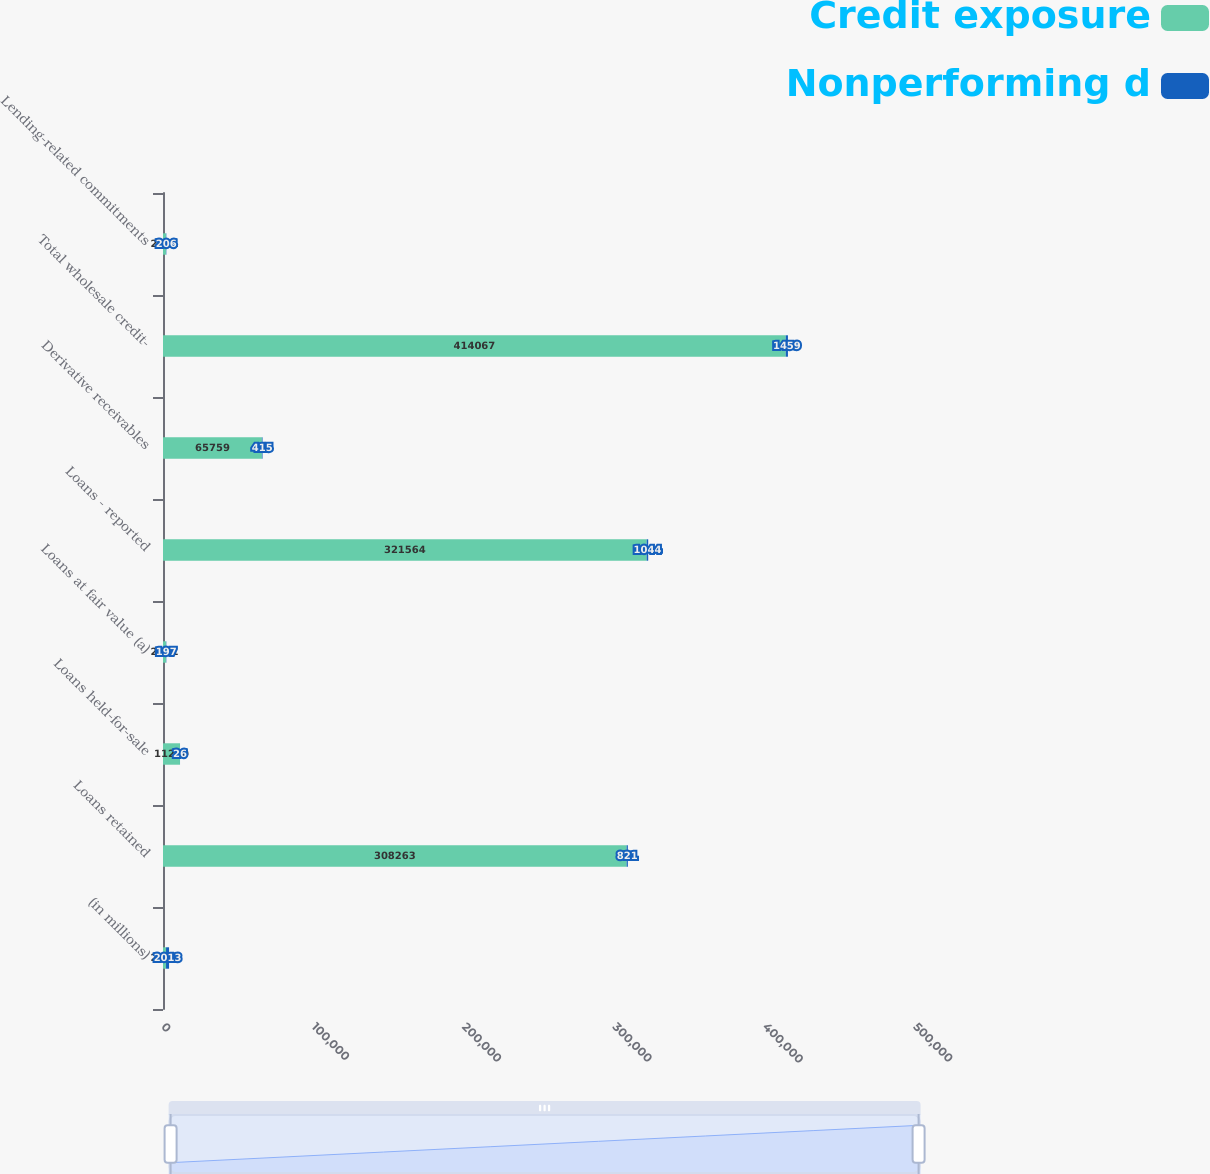Convert chart to OTSL. <chart><loc_0><loc_0><loc_500><loc_500><stacked_bar_chart><ecel><fcel>(in millions)<fcel>Loans retained<fcel>Loans held-for-sale<fcel>Loans at fair value (a)<fcel>Loans - reported<fcel>Derivative receivables<fcel>Total wholesale credit-<fcel>Lending-related commitments<nl><fcel>Credit exposure<fcel>2013<fcel>308263<fcel>11290<fcel>2011<fcel>321564<fcel>65759<fcel>414067<fcel>2011<nl><fcel>Nonperforming d<fcel>2013<fcel>821<fcel>26<fcel>197<fcel>1044<fcel>415<fcel>1459<fcel>206<nl></chart> 